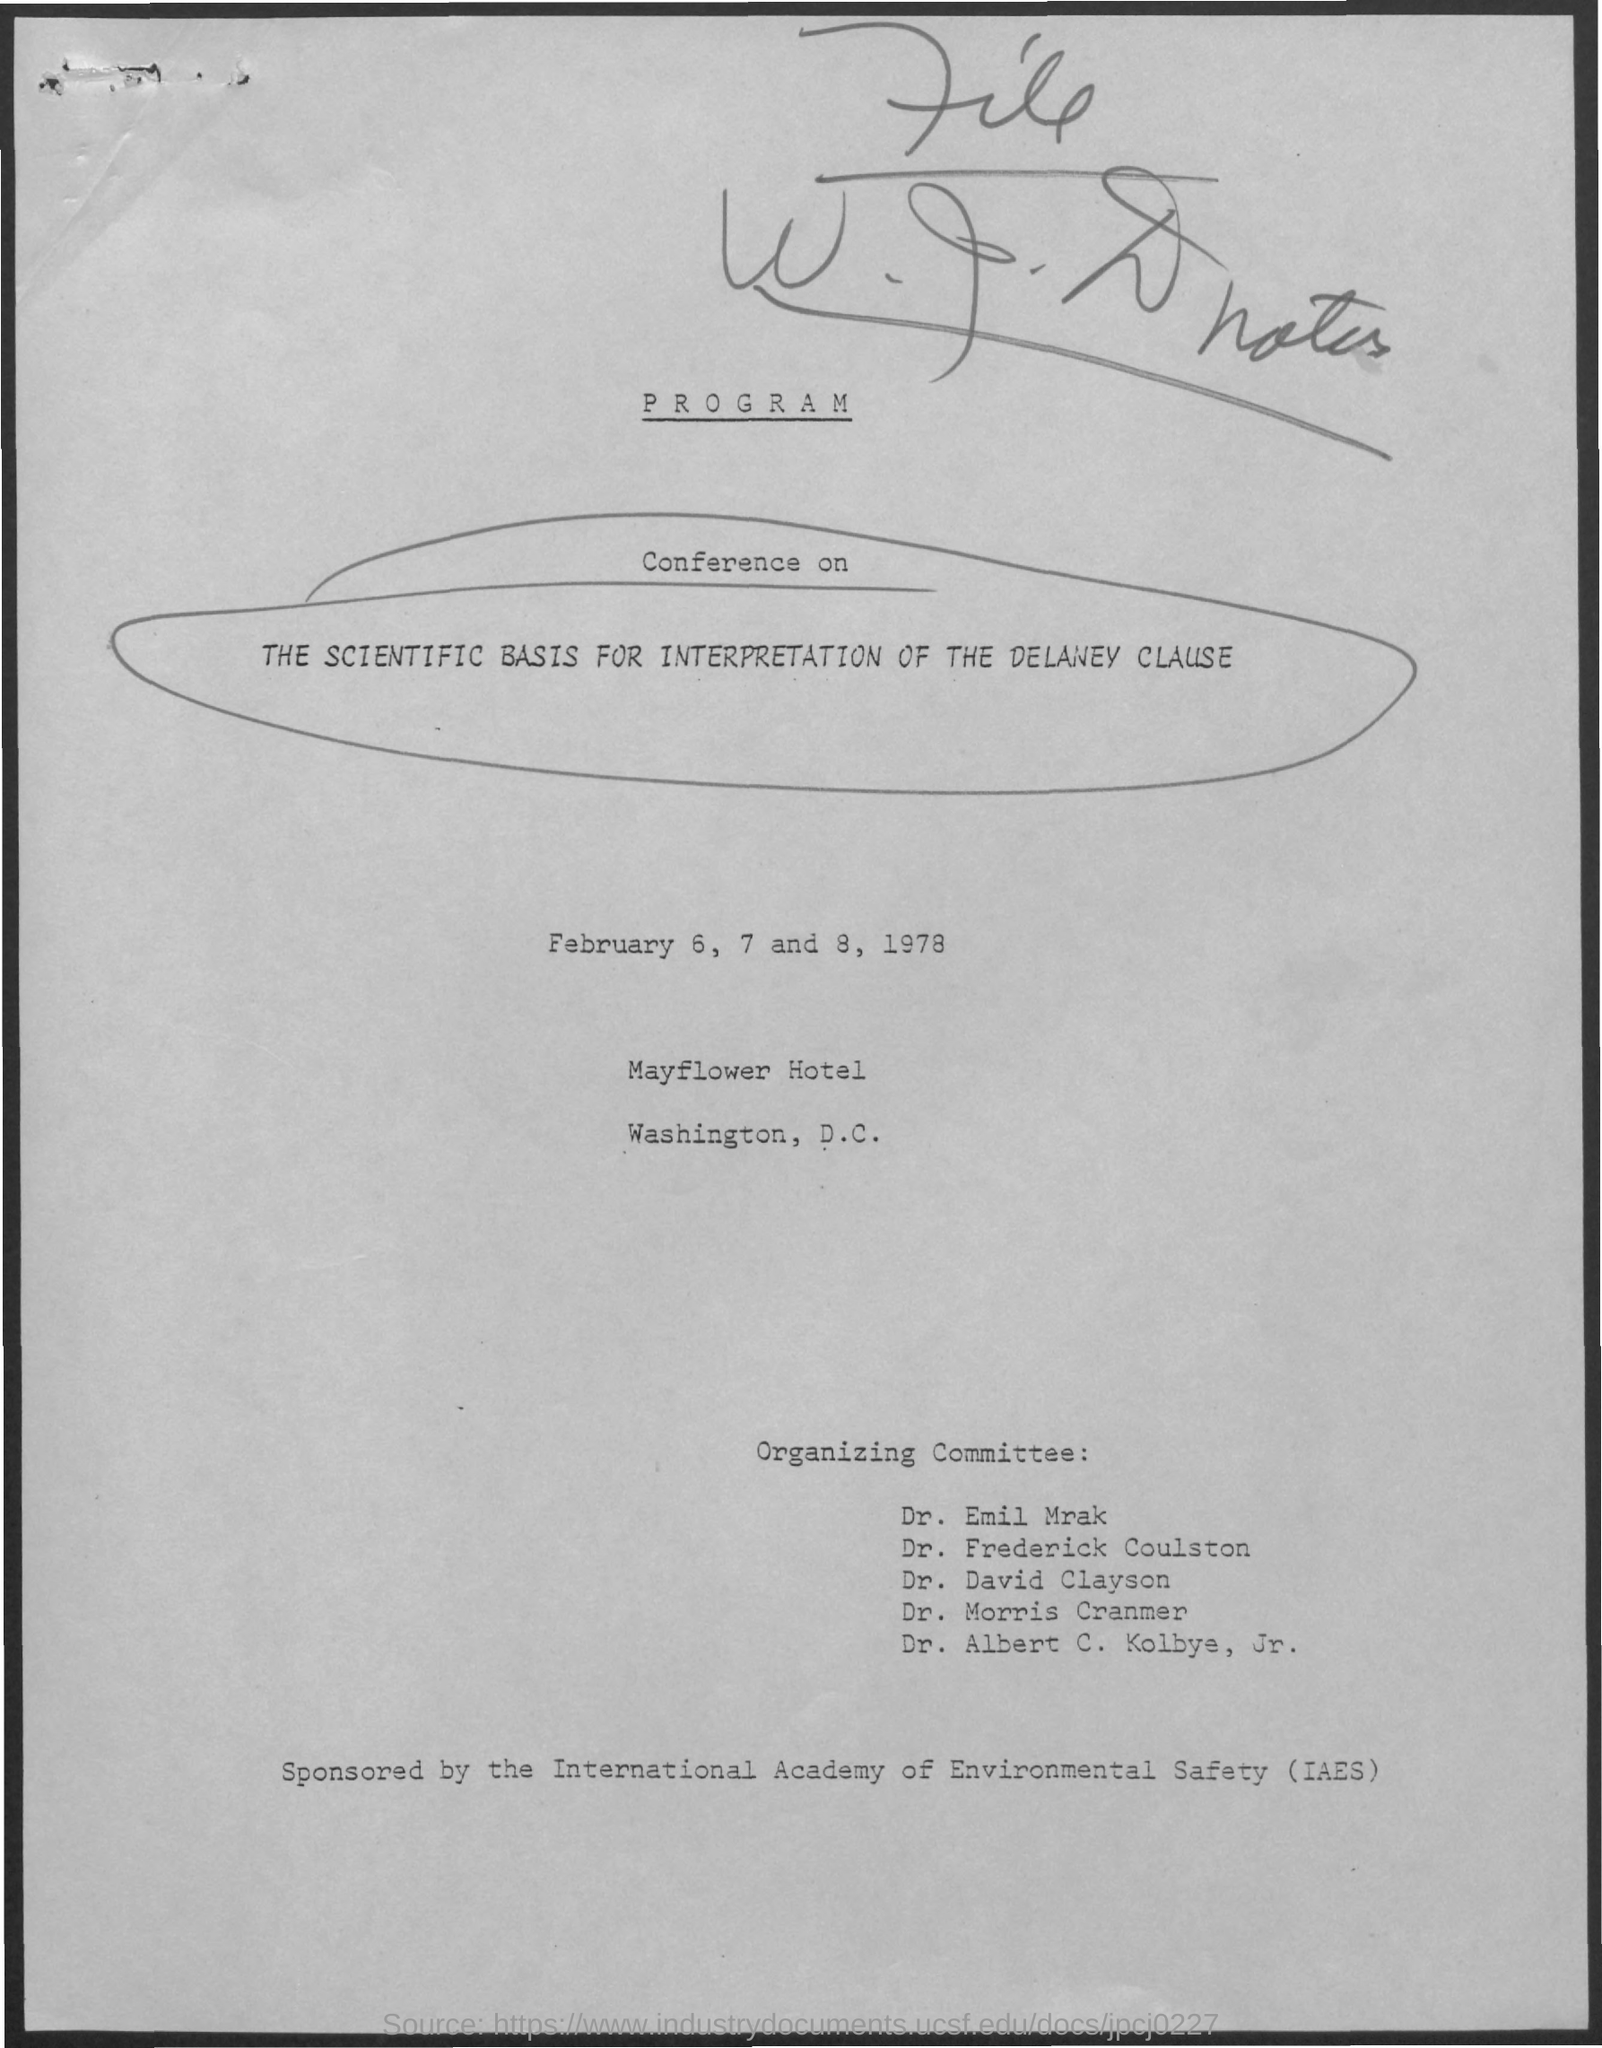When is the Conference?
Your response must be concise. February 6, 7 and 8, 1978. What is the Title of the document?
Your response must be concise. Program. 